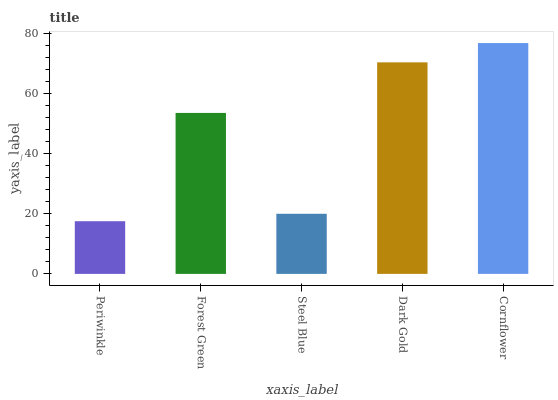Is Periwinkle the minimum?
Answer yes or no. Yes. Is Cornflower the maximum?
Answer yes or no. Yes. Is Forest Green the minimum?
Answer yes or no. No. Is Forest Green the maximum?
Answer yes or no. No. Is Forest Green greater than Periwinkle?
Answer yes or no. Yes. Is Periwinkle less than Forest Green?
Answer yes or no. Yes. Is Periwinkle greater than Forest Green?
Answer yes or no. No. Is Forest Green less than Periwinkle?
Answer yes or no. No. Is Forest Green the high median?
Answer yes or no. Yes. Is Forest Green the low median?
Answer yes or no. Yes. Is Periwinkle the high median?
Answer yes or no. No. Is Steel Blue the low median?
Answer yes or no. No. 